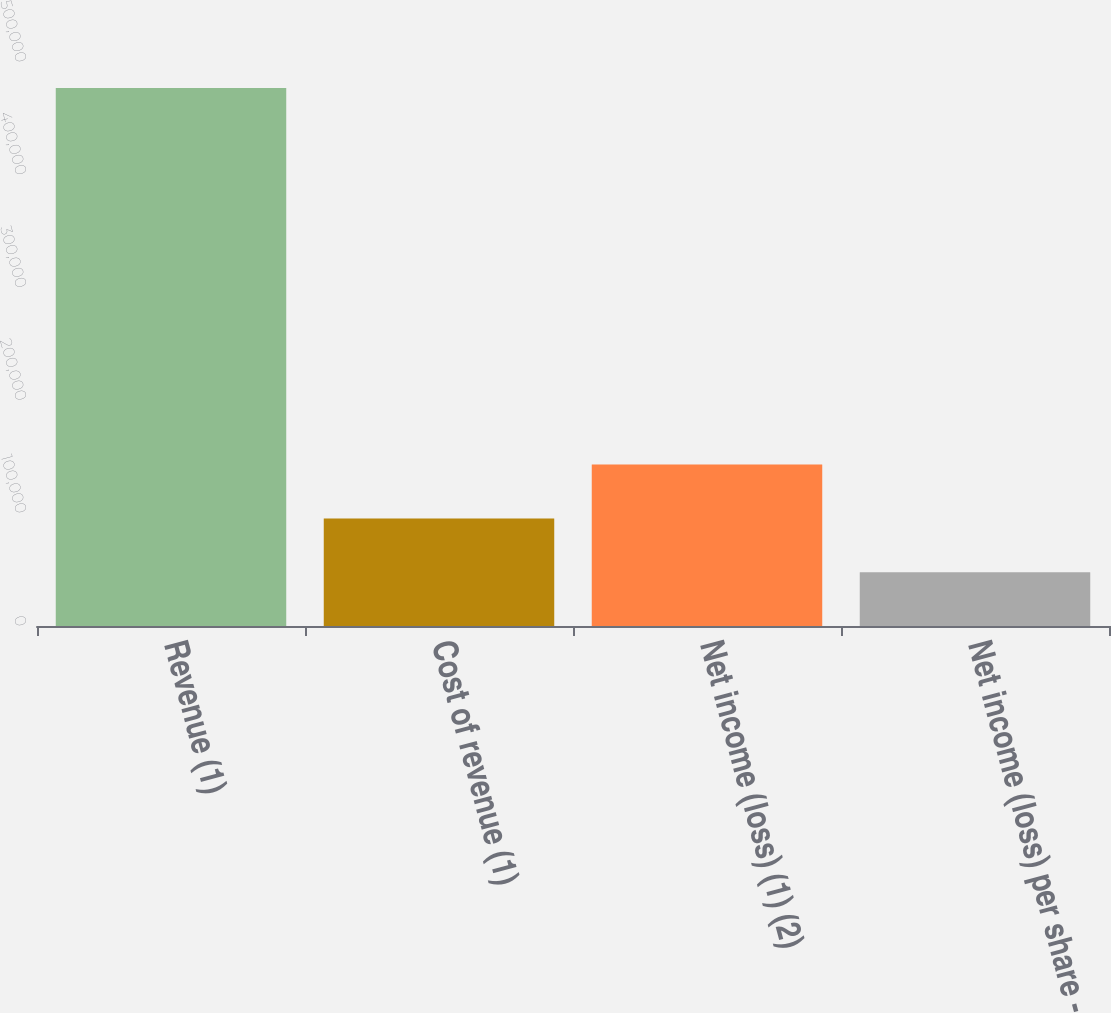Convert chart to OTSL. <chart><loc_0><loc_0><loc_500><loc_500><bar_chart><fcel>Revenue (1)<fcel>Cost of revenue (1)<fcel>Net income (loss) (1) (2)<fcel>Net income (loss) per share -<nl><fcel>476911<fcel>95382.4<fcel>143073<fcel>47691.3<nl></chart> 